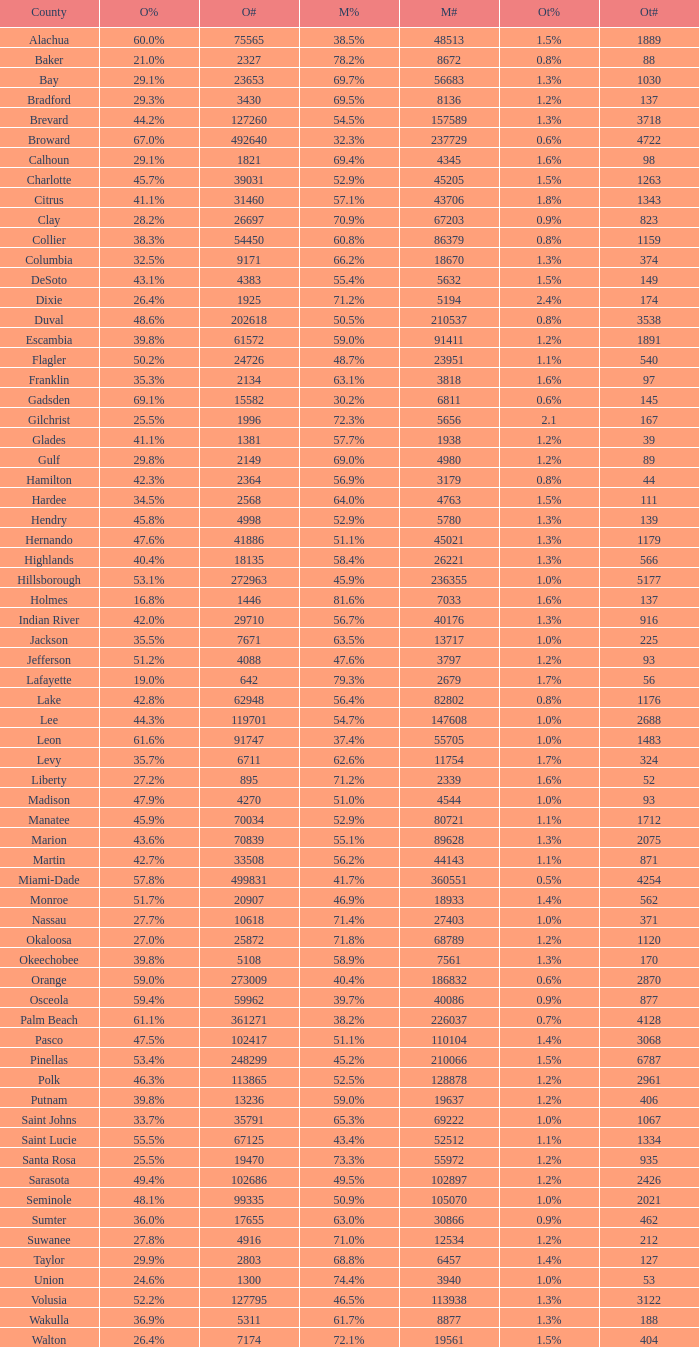What was the total of voters backing mccain when obama secured 895? 2339.0. 